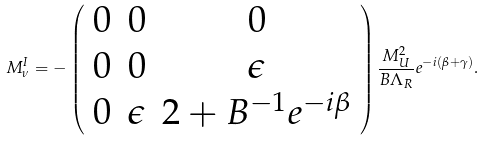<formula> <loc_0><loc_0><loc_500><loc_500>M ^ { I } _ { \nu } = - \left ( \begin{array} { c c c } 0 & 0 & 0 \\ 0 & 0 & \epsilon \\ 0 & \epsilon & 2 + B ^ { - 1 } e ^ { - i \beta } \end{array} \right ) \frac { M _ { U } ^ { 2 } } { B \Lambda _ { R } } e ^ { - i ( \beta + \gamma ) } .</formula> 